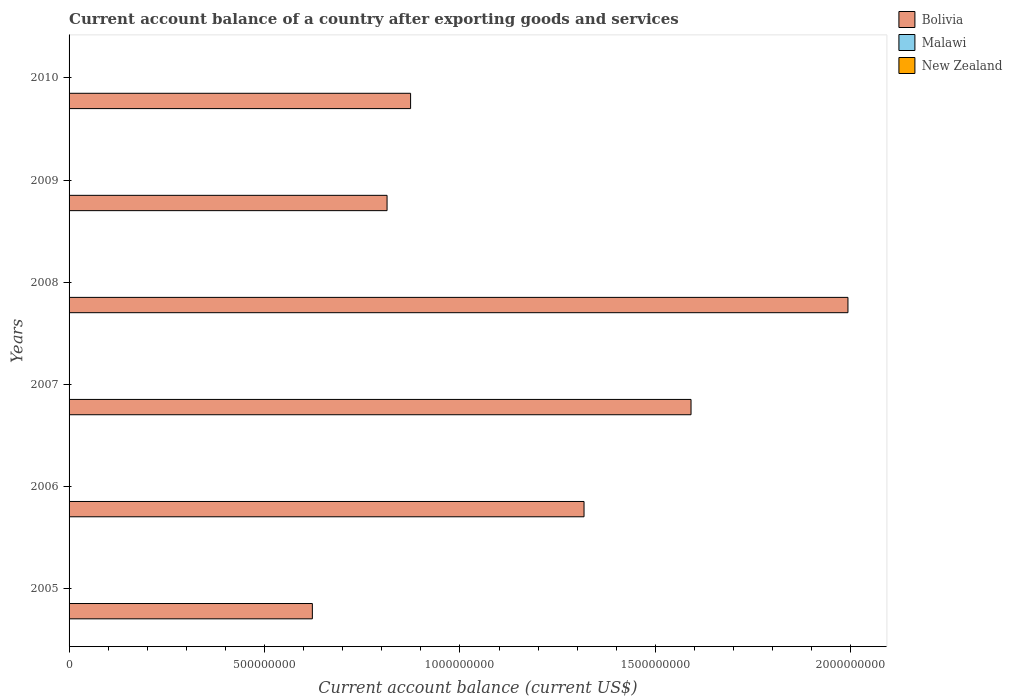How many different coloured bars are there?
Give a very brief answer. 1. Are the number of bars per tick equal to the number of legend labels?
Offer a terse response. No. What is the account balance in Malawi in 2010?
Your answer should be compact. 0. Across all years, what is the maximum account balance in Bolivia?
Provide a succinct answer. 1.99e+09. Across all years, what is the minimum account balance in Bolivia?
Offer a terse response. 6.22e+08. In which year was the account balance in Bolivia maximum?
Provide a succinct answer. 2008. What is the total account balance in Bolivia in the graph?
Offer a terse response. 7.21e+09. What is the difference between the account balance in Bolivia in 2008 and that in 2010?
Make the answer very short. 1.12e+09. What is the difference between the account balance in Malawi in 2006 and the account balance in Bolivia in 2007?
Ensure brevity in your answer.  -1.59e+09. In how many years, is the account balance in New Zealand greater than 1800000000 US$?
Keep it short and to the point. 0. What is the ratio of the account balance in Bolivia in 2006 to that in 2009?
Provide a succinct answer. 1.62. What is the difference between the highest and the second highest account balance in Bolivia?
Make the answer very short. 4.01e+08. What is the difference between the highest and the lowest account balance in Bolivia?
Keep it short and to the point. 1.37e+09. Is it the case that in every year, the sum of the account balance in Malawi and account balance in New Zealand is greater than the account balance in Bolivia?
Your answer should be compact. No. What is the difference between two consecutive major ticks on the X-axis?
Your response must be concise. 5.00e+08. Does the graph contain any zero values?
Offer a very short reply. Yes. How many legend labels are there?
Your answer should be very brief. 3. What is the title of the graph?
Make the answer very short. Current account balance of a country after exporting goods and services. Does "South Africa" appear as one of the legend labels in the graph?
Provide a short and direct response. No. What is the label or title of the X-axis?
Make the answer very short. Current account balance (current US$). What is the label or title of the Y-axis?
Your answer should be compact. Years. What is the Current account balance (current US$) of Bolivia in 2005?
Ensure brevity in your answer.  6.22e+08. What is the Current account balance (current US$) in Malawi in 2005?
Provide a short and direct response. 0. What is the Current account balance (current US$) of New Zealand in 2005?
Give a very brief answer. 0. What is the Current account balance (current US$) of Bolivia in 2006?
Give a very brief answer. 1.32e+09. What is the Current account balance (current US$) of Bolivia in 2007?
Give a very brief answer. 1.59e+09. What is the Current account balance (current US$) in Bolivia in 2008?
Keep it short and to the point. 1.99e+09. What is the Current account balance (current US$) in Malawi in 2008?
Your response must be concise. 0. What is the Current account balance (current US$) in New Zealand in 2008?
Make the answer very short. 0. What is the Current account balance (current US$) in Bolivia in 2009?
Offer a terse response. 8.14e+08. What is the Current account balance (current US$) of Bolivia in 2010?
Ensure brevity in your answer.  8.74e+08. What is the Current account balance (current US$) in New Zealand in 2010?
Offer a very short reply. 0. Across all years, what is the maximum Current account balance (current US$) of Bolivia?
Provide a short and direct response. 1.99e+09. Across all years, what is the minimum Current account balance (current US$) in Bolivia?
Provide a short and direct response. 6.22e+08. What is the total Current account balance (current US$) of Bolivia in the graph?
Your answer should be very brief. 7.21e+09. What is the difference between the Current account balance (current US$) of Bolivia in 2005 and that in 2006?
Offer a very short reply. -6.95e+08. What is the difference between the Current account balance (current US$) of Bolivia in 2005 and that in 2007?
Provide a short and direct response. -9.69e+08. What is the difference between the Current account balance (current US$) in Bolivia in 2005 and that in 2008?
Make the answer very short. -1.37e+09. What is the difference between the Current account balance (current US$) in Bolivia in 2005 and that in 2009?
Keep it short and to the point. -1.91e+08. What is the difference between the Current account balance (current US$) of Bolivia in 2005 and that in 2010?
Give a very brief answer. -2.51e+08. What is the difference between the Current account balance (current US$) of Bolivia in 2006 and that in 2007?
Keep it short and to the point. -2.74e+08. What is the difference between the Current account balance (current US$) in Bolivia in 2006 and that in 2008?
Keep it short and to the point. -6.75e+08. What is the difference between the Current account balance (current US$) in Bolivia in 2006 and that in 2009?
Keep it short and to the point. 5.04e+08. What is the difference between the Current account balance (current US$) of Bolivia in 2006 and that in 2010?
Ensure brevity in your answer.  4.44e+08. What is the difference between the Current account balance (current US$) of Bolivia in 2007 and that in 2008?
Your answer should be very brief. -4.01e+08. What is the difference between the Current account balance (current US$) of Bolivia in 2007 and that in 2009?
Your response must be concise. 7.78e+08. What is the difference between the Current account balance (current US$) of Bolivia in 2007 and that in 2010?
Provide a short and direct response. 7.18e+08. What is the difference between the Current account balance (current US$) of Bolivia in 2008 and that in 2009?
Your response must be concise. 1.18e+09. What is the difference between the Current account balance (current US$) in Bolivia in 2008 and that in 2010?
Offer a very short reply. 1.12e+09. What is the difference between the Current account balance (current US$) in Bolivia in 2009 and that in 2010?
Provide a short and direct response. -6.02e+07. What is the average Current account balance (current US$) of Bolivia per year?
Offer a terse response. 1.20e+09. What is the average Current account balance (current US$) of Malawi per year?
Give a very brief answer. 0. What is the average Current account balance (current US$) in New Zealand per year?
Keep it short and to the point. 0. What is the ratio of the Current account balance (current US$) in Bolivia in 2005 to that in 2006?
Give a very brief answer. 0.47. What is the ratio of the Current account balance (current US$) in Bolivia in 2005 to that in 2007?
Your answer should be compact. 0.39. What is the ratio of the Current account balance (current US$) of Bolivia in 2005 to that in 2008?
Your answer should be compact. 0.31. What is the ratio of the Current account balance (current US$) in Bolivia in 2005 to that in 2009?
Your response must be concise. 0.77. What is the ratio of the Current account balance (current US$) of Bolivia in 2005 to that in 2010?
Offer a very short reply. 0.71. What is the ratio of the Current account balance (current US$) in Bolivia in 2006 to that in 2007?
Give a very brief answer. 0.83. What is the ratio of the Current account balance (current US$) in Bolivia in 2006 to that in 2008?
Provide a short and direct response. 0.66. What is the ratio of the Current account balance (current US$) of Bolivia in 2006 to that in 2009?
Ensure brevity in your answer.  1.62. What is the ratio of the Current account balance (current US$) of Bolivia in 2006 to that in 2010?
Your answer should be compact. 1.51. What is the ratio of the Current account balance (current US$) in Bolivia in 2007 to that in 2008?
Give a very brief answer. 0.8. What is the ratio of the Current account balance (current US$) of Bolivia in 2007 to that in 2009?
Provide a succinct answer. 1.96. What is the ratio of the Current account balance (current US$) of Bolivia in 2007 to that in 2010?
Make the answer very short. 1.82. What is the ratio of the Current account balance (current US$) of Bolivia in 2008 to that in 2009?
Give a very brief answer. 2.45. What is the ratio of the Current account balance (current US$) in Bolivia in 2008 to that in 2010?
Your answer should be very brief. 2.28. What is the ratio of the Current account balance (current US$) of Bolivia in 2009 to that in 2010?
Make the answer very short. 0.93. What is the difference between the highest and the second highest Current account balance (current US$) in Bolivia?
Your answer should be very brief. 4.01e+08. What is the difference between the highest and the lowest Current account balance (current US$) in Bolivia?
Keep it short and to the point. 1.37e+09. 